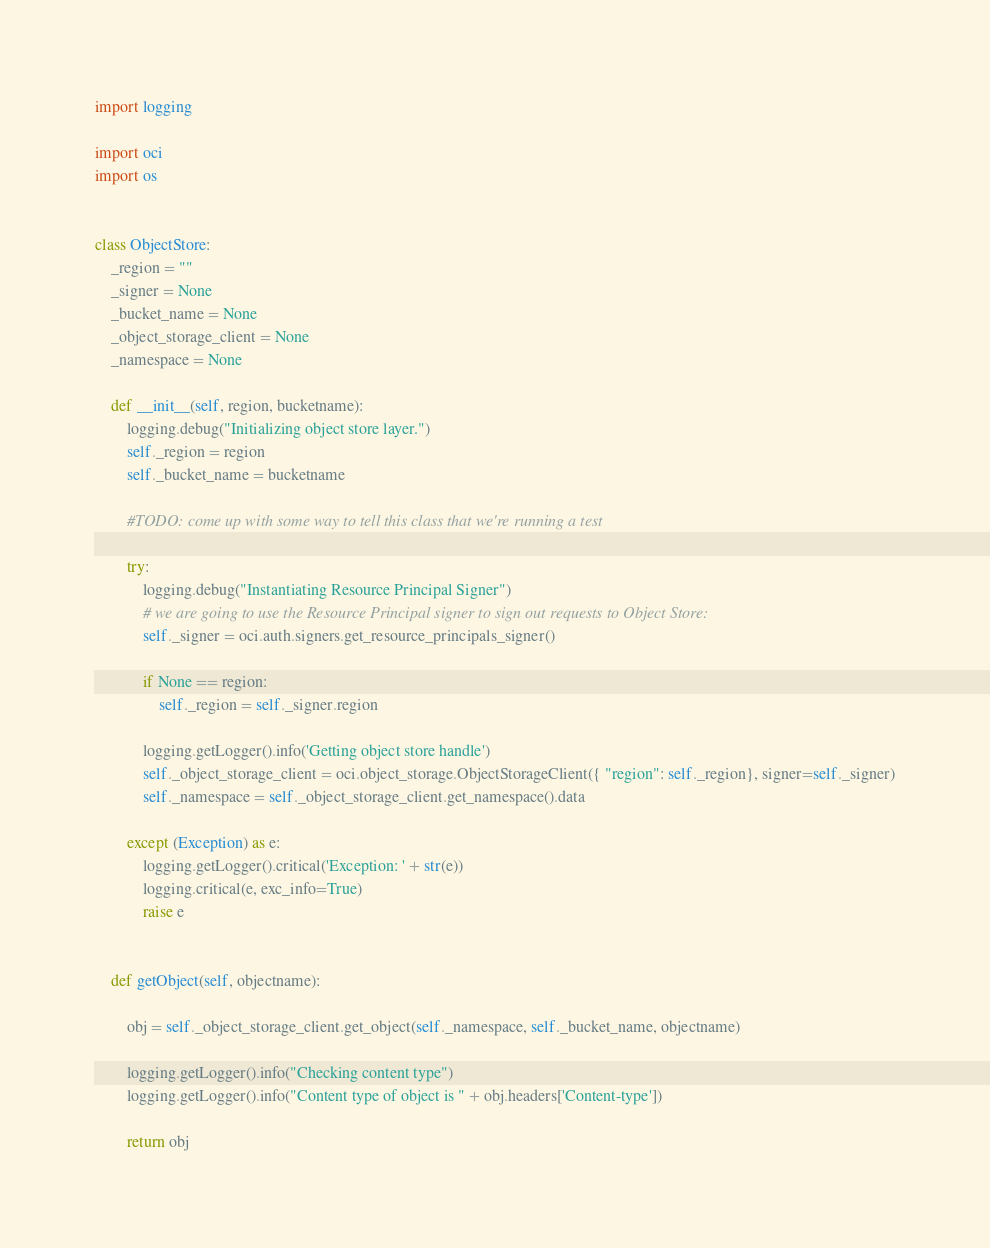Convert code to text. <code><loc_0><loc_0><loc_500><loc_500><_Python_>import logging

import oci
import os


class ObjectStore:
    _region = ""
    _signer = None
    _bucket_name = None
    _object_storage_client = None
    _namespace = None

    def __init__(self, region, bucketname):
        logging.debug("Initializing object store layer.")
        self._region = region
        self._bucket_name = bucketname

        #TODO: come up with some way to tell this class that we're running a test

        try:
            logging.debug("Instantiating Resource Principal Signer")
            # we are going to use the Resource Principal signer to sign out requests to Object Store:
            self._signer = oci.auth.signers.get_resource_principals_signer()

            if None == region:
                self._region = self._signer.region

            logging.getLogger().info('Getting object store handle')
            self._object_storage_client = oci.object_storage.ObjectStorageClient({ "region": self._region}, signer=self._signer)
            self._namespace = self._object_storage_client.get_namespace().data

        except (Exception) as e:
            logging.getLogger().critical('Exception: ' + str(e))
            logging.critical(e, exc_info=True)
            raise e


    def getObject(self, objectname):

        obj = self._object_storage_client.get_object(self._namespace, self._bucket_name, objectname)

        logging.getLogger().info("Checking content type")
        logging.getLogger().info("Content type of object is " + obj.headers['Content-type'])

        return obj

</code> 